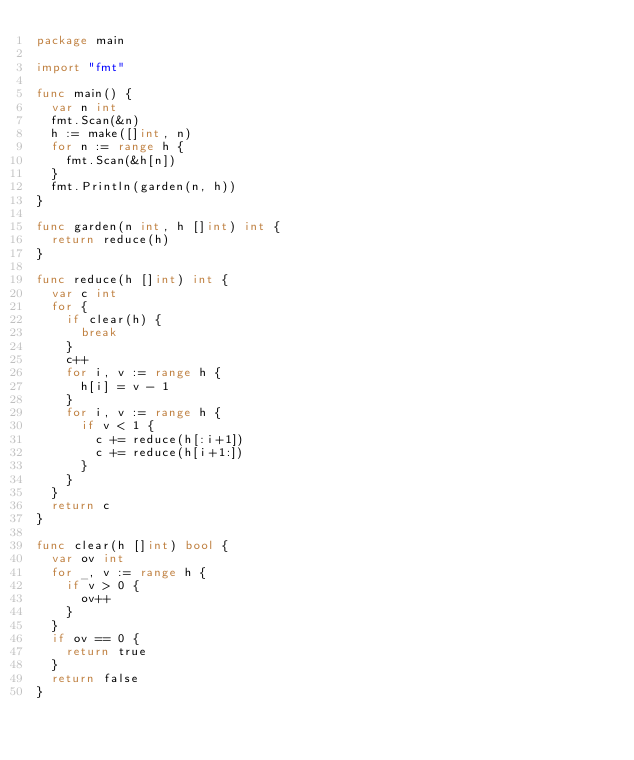Convert code to text. <code><loc_0><loc_0><loc_500><loc_500><_Go_>package main

import "fmt"

func main() {
	var n int
	fmt.Scan(&n)
	h := make([]int, n)
	for n := range h {
		fmt.Scan(&h[n])
	}
	fmt.Println(garden(n, h))
}

func garden(n int, h []int) int {
	return reduce(h)
}

func reduce(h []int) int {
	var c int
	for {
		if clear(h) {
			break
		}
		c++
		for i, v := range h {
			h[i] = v - 1
		}
		for i, v := range h {
			if v < 1 {
				c += reduce(h[:i+1])
				c += reduce(h[i+1:])
			}
		}
	}
	return c
}

func clear(h []int) bool {
	var ov int
	for _, v := range h {
		if v > 0 {
			ov++
		}
	}
	if ov == 0 {
		return true
	}
	return false
}
</code> 